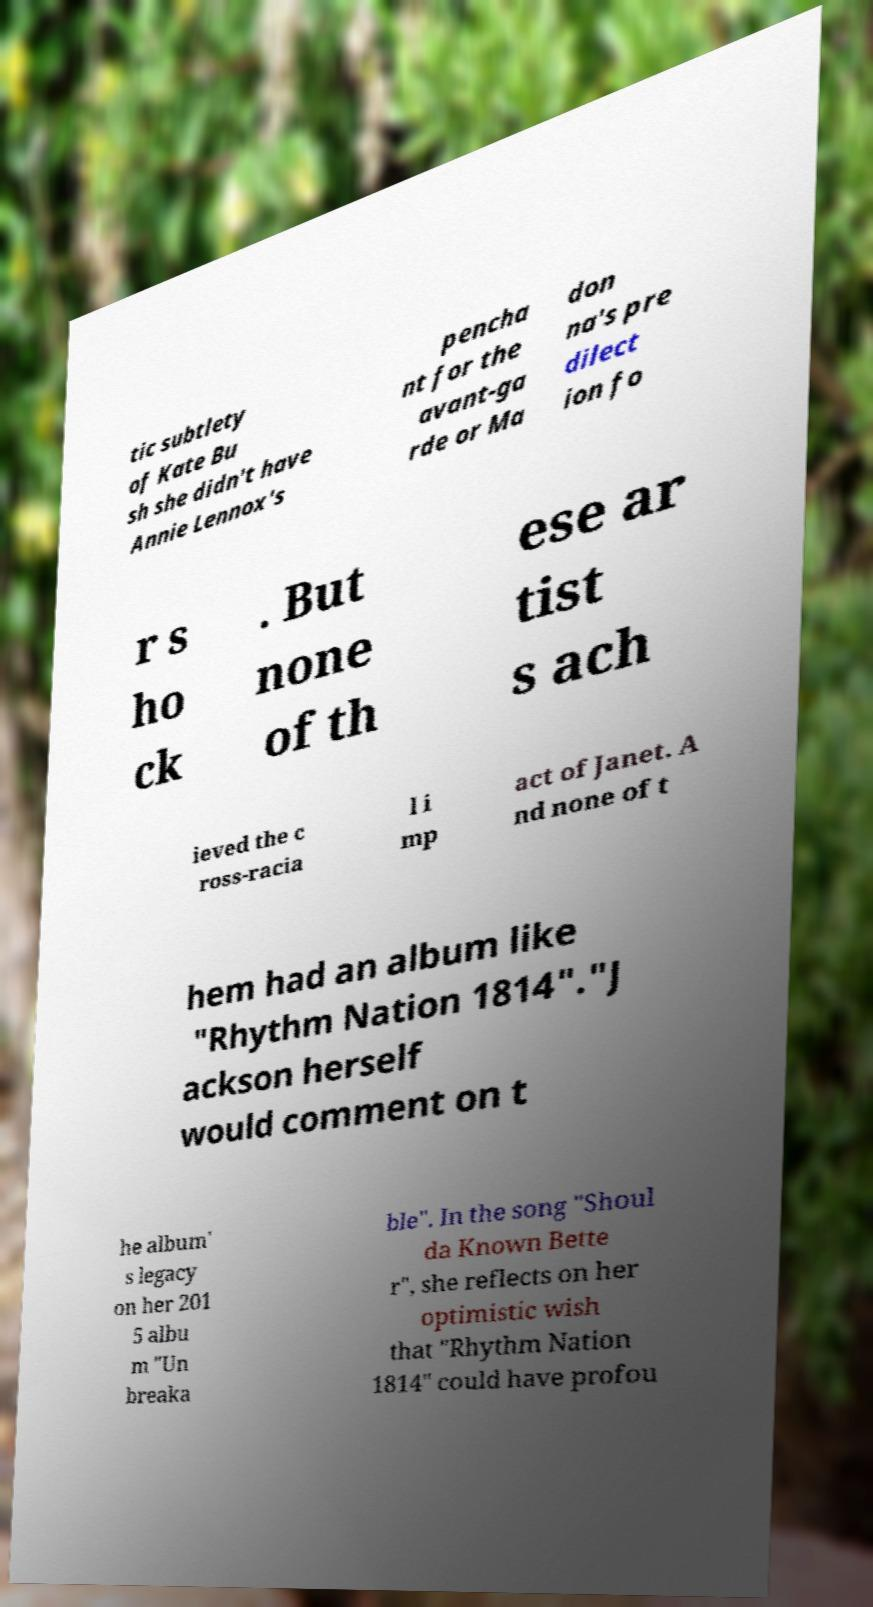For documentation purposes, I need the text within this image transcribed. Could you provide that? tic subtlety of Kate Bu sh she didn't have Annie Lennox's pencha nt for the avant-ga rde or Ma don na's pre dilect ion fo r s ho ck . But none of th ese ar tist s ach ieved the c ross-racia l i mp act of Janet. A nd none of t hem had an album like "Rhythm Nation 1814"."J ackson herself would comment on t he album' s legacy on her 201 5 albu m "Un breaka ble". In the song "Shoul da Known Bette r", she reflects on her optimistic wish that "Rhythm Nation 1814" could have profou 